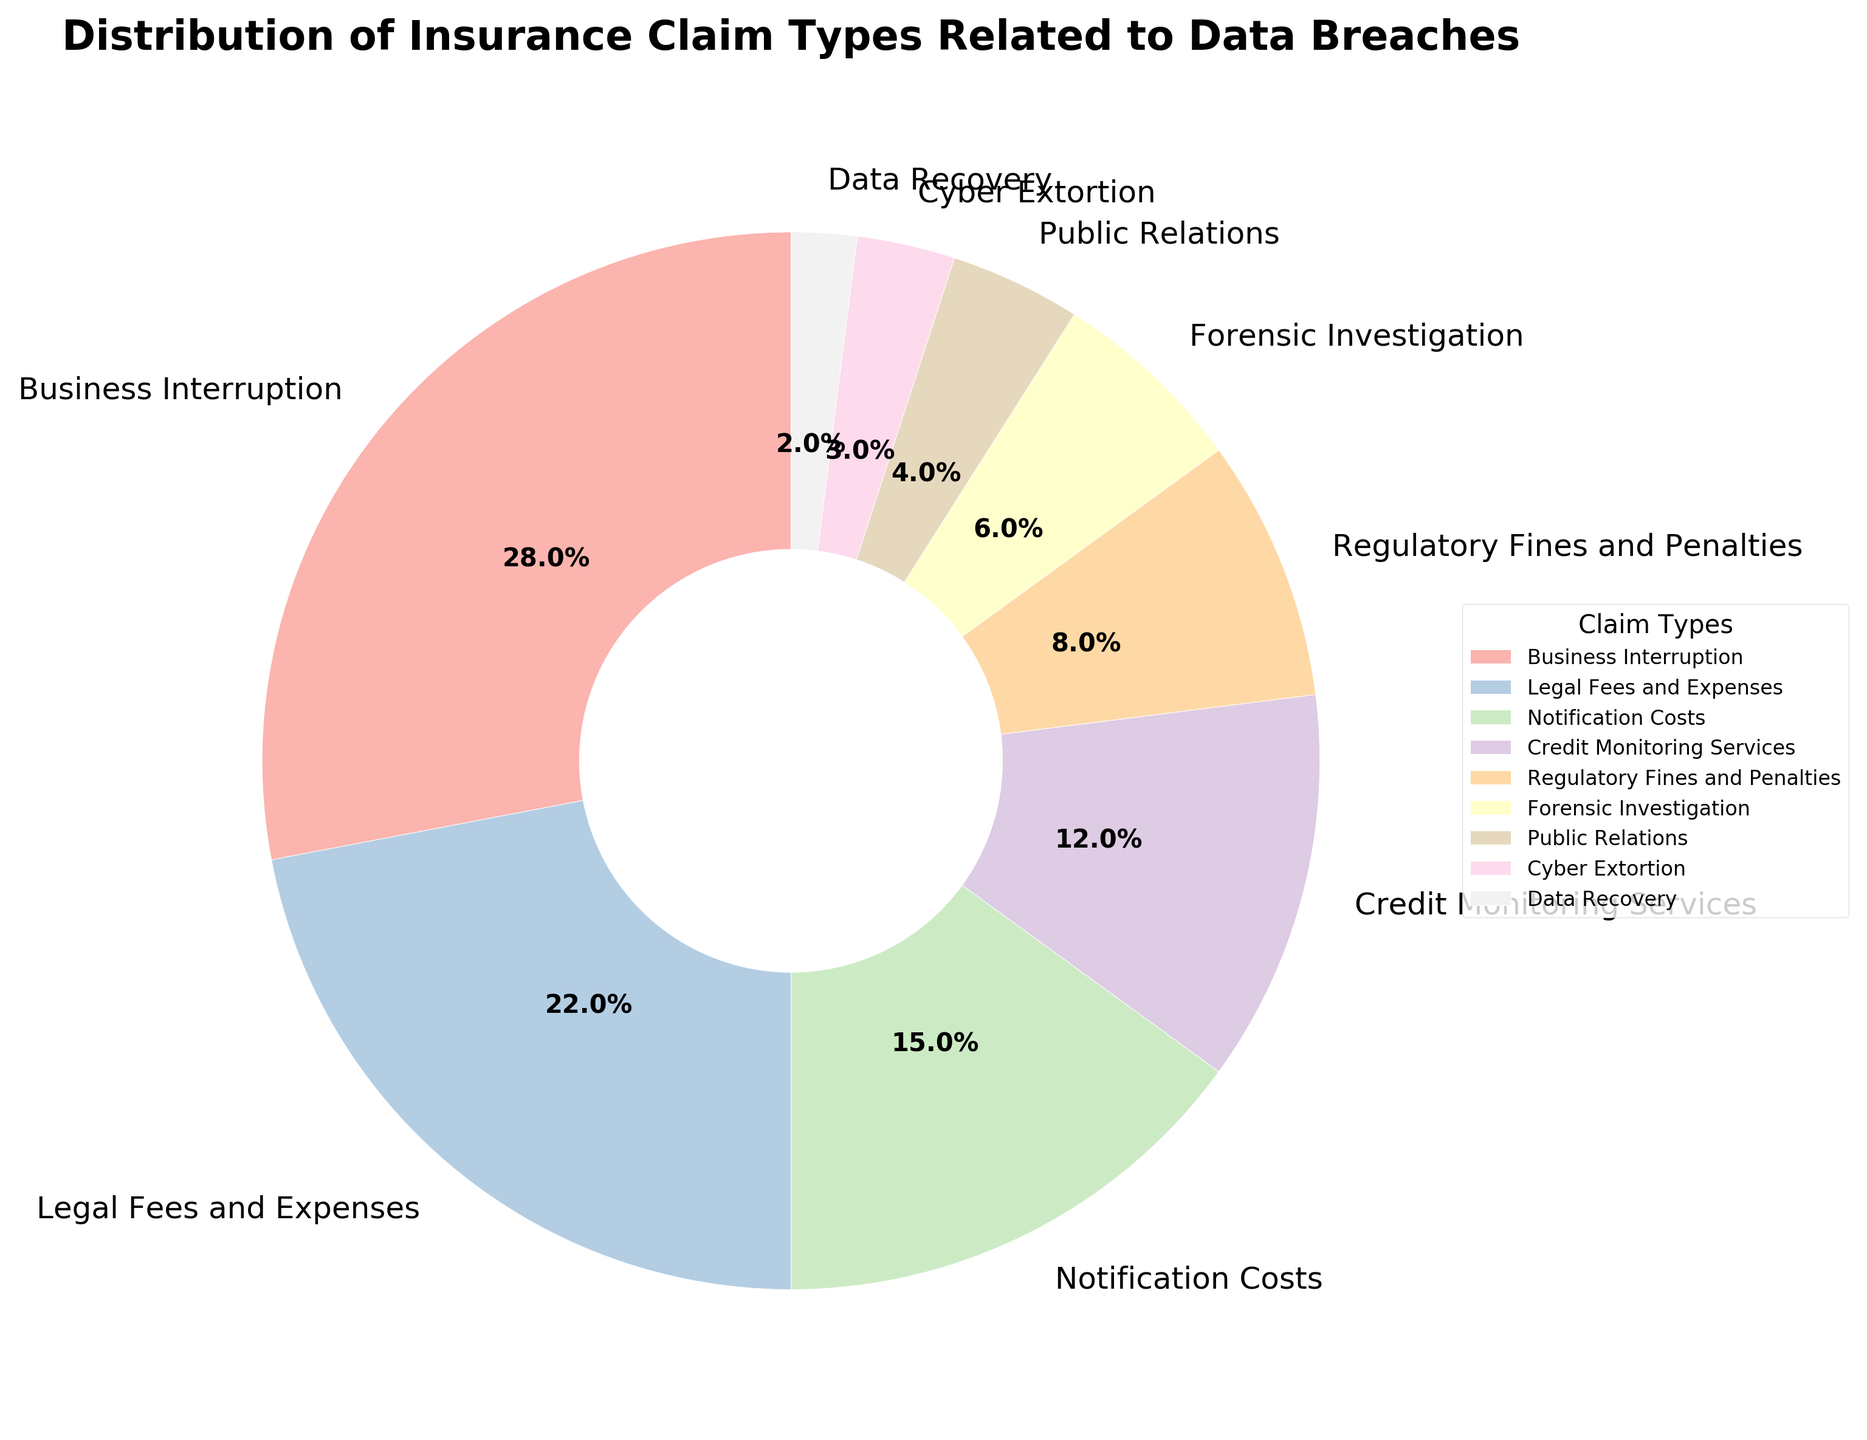Which claim type has the highest percentage? By looking at the pie chart, we see that the segment labeled "Business Interruption" is the largest slice.
Answer: Business Interruption What is the combined percentage of Notification Costs and Credit Monitoring Services? Notification Costs is 15% and Credit Monitoring Services is 12%. Adding these together, 15 + 12 = 27%.
Answer: 27% Which two claim types have the smallest percentages, and what is their total percentage? The smallest segments are Data Recovery at 2% and Cyber Extortion at 3%. Adding these together, 2 + 3 = 5%.
Answer: Data Recovery and Cyber Extortion, 5% Is the sum of percentages for Business Interruption and Legal Fees and Expenses greater or less than 50%? Business Interruption is 28% and Legal Fees and Expenses is 22%. Adding these together gives 28 + 22 = 50%, which is exactly 50%.
Answer: Equal to 50% Which claim type has a percentage that is twice the percentage of Forensic Investigation? Forensic Investigation is 6%. The claim type that is twice of 6% is 12%, which matches Credit Monitoring Services at 12%.
Answer: Credit Monitoring Services What's the difference in percentage between Regulatory Fines and Penalties and Public Relations? Regulatory Fines and Penalties are 8%, and Public Relations are 4%. The difference is 8 - 4 = 4%.
Answer: 4% How many claim types have a percentage greater than 10%? Business Interruption (28%), Legal Fees and Expenses (22%), Notification Costs (15%), and Credit Monitoring Services (12%) all have percentages greater than 10%. This makes a total of 4 claim types.
Answer: 4 claim types What is the average percentage of the claim types that fall under 10%? The claim types under 10% are Regulatory Fines and Penalties (8%), Forensic Investigation (6%), Public Relations (4%), Cyber Extortion (3%), and Data Recovery (2%). Their average percentage is (8 + 6 + 4 + 3 + 2) / 5 = 4.6%.
Answer: 4.6% Which claim type is represented by the lightest color in the pie chart? By looking at the pie chart's color gradient where lighter colors are on one side, the lightest color corresponds to Data Recovery.
Answer: Data Recovery 